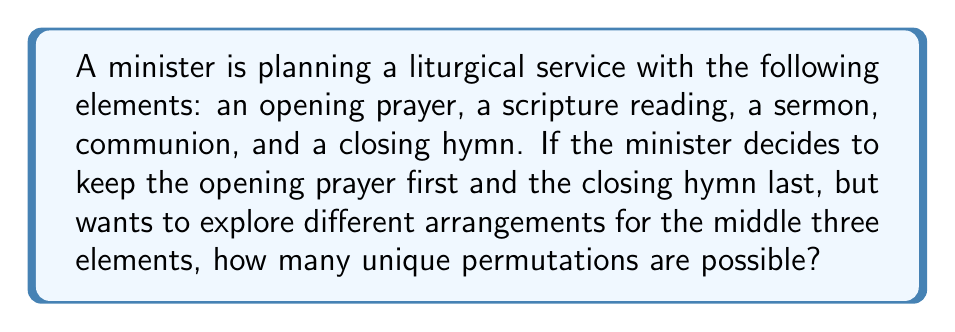Could you help me with this problem? To solve this problem, we'll use concepts from permutation theory in Group theory.

1) First, we need to identify the number of elements that can be rearranged. In this case, we have 3 elements (scripture reading, sermon, and communion) that can be reordered.

2) The number of permutations of n distinct objects is given by n!. In this case, n = 3.

3) Therefore, the number of permutations is:

   $$ 3! = 3 \times 2 \times 1 = 6 $$

4) We can list out these permutations to verify:
   - Scripture reading, Sermon, Communion
   - Scripture reading, Communion, Sermon
   - Sermon, Scripture reading, Communion
   - Sermon, Communion, Scripture reading
   - Communion, Scripture reading, Sermon
   - Communion, Sermon, Scripture reading

5) Each of these arrangements will be preceded by the opening prayer and followed by the closing hymn, resulting in 6 unique liturgical arrangements.

This problem demonstrates how permutations can be applied to liturgical practices, allowing for variety while maintaining the essential structure of the service.
Answer: 6 unique permutations 